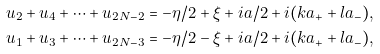<formula> <loc_0><loc_0><loc_500><loc_500>u _ { 2 } + u _ { 4 } + \cdots + u _ { 2 N - 2 } = - \eta / 2 + \xi + i a / 2 + i ( k a _ { + } + l a _ { - } ) , \\ u _ { 1 } + u _ { 3 } + \cdots + u _ { 2 N - 3 } = - \eta / 2 - \xi + i a / 2 + i ( k a _ { + } + l a _ { - } ) ,</formula> 